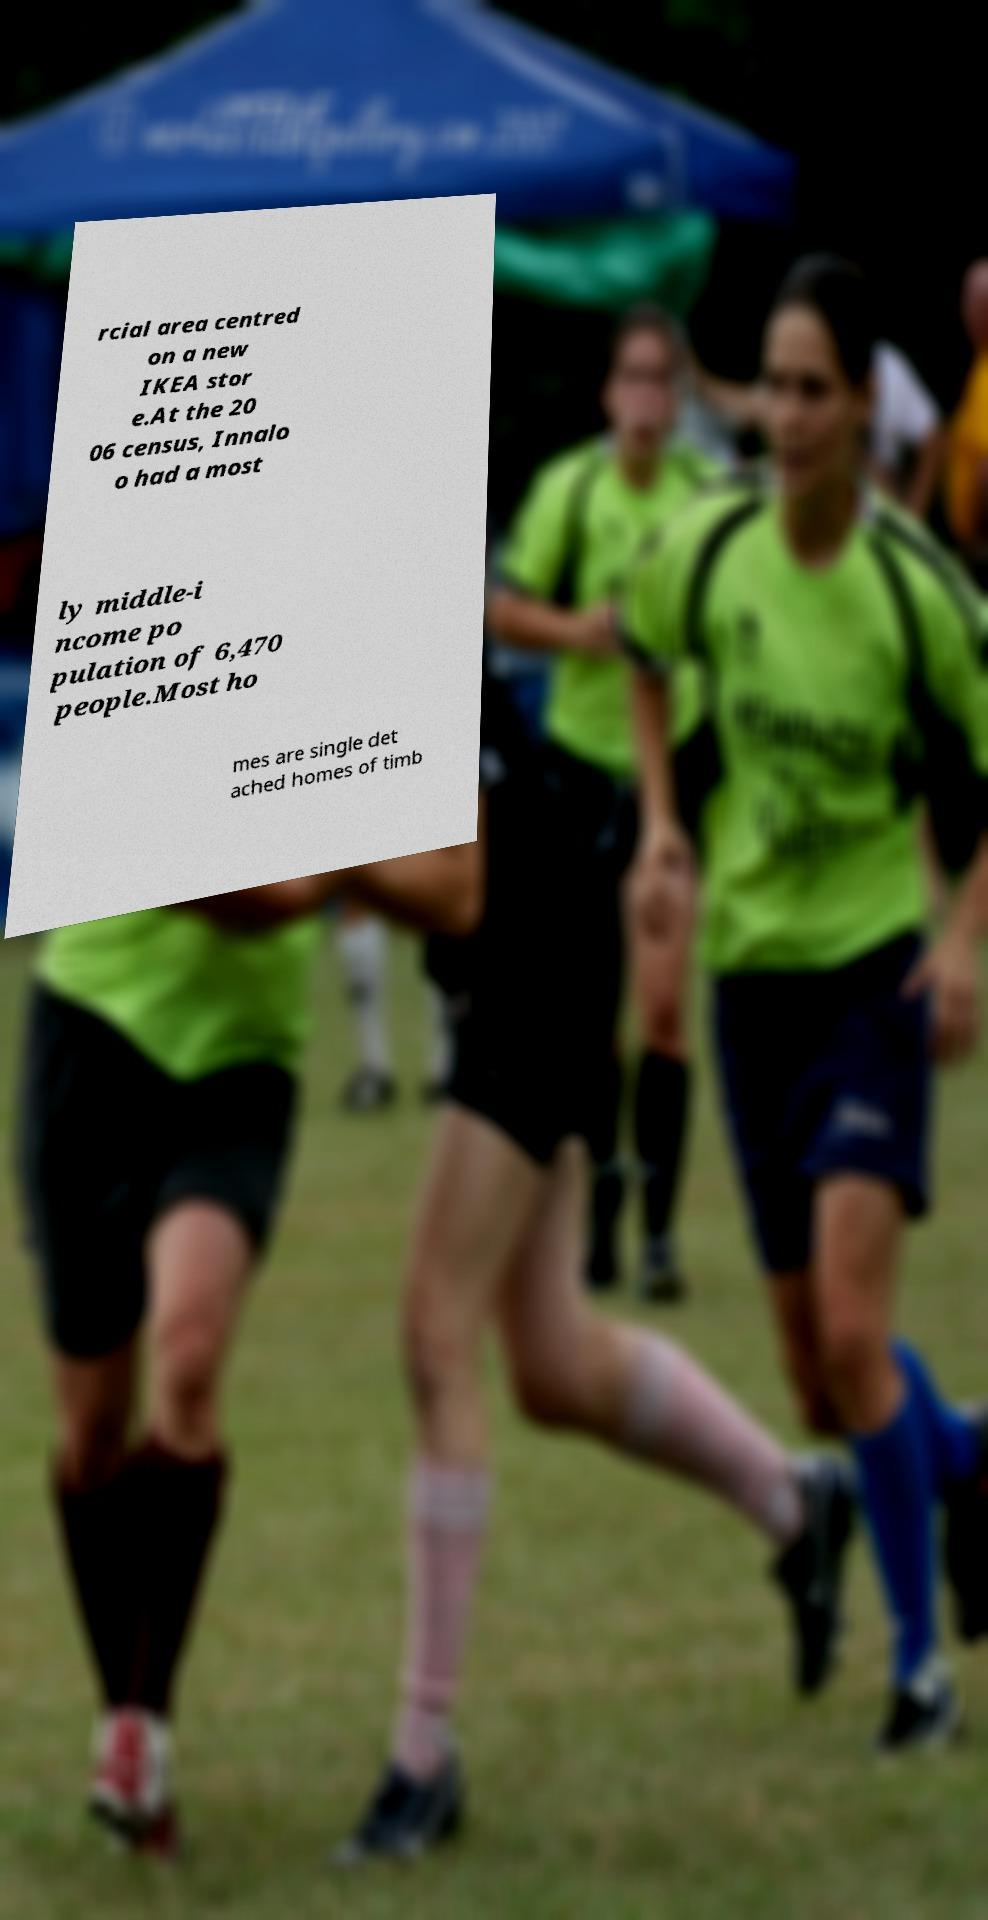Could you assist in decoding the text presented in this image and type it out clearly? rcial area centred on a new IKEA stor e.At the 20 06 census, Innalo o had a most ly middle-i ncome po pulation of 6,470 people.Most ho mes are single det ached homes of timb 